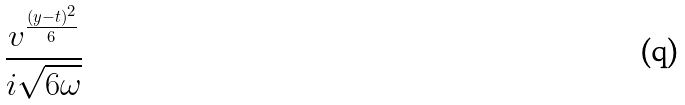<formula> <loc_0><loc_0><loc_500><loc_500>\frac { v ^ { \frac { ( y - t ) ^ { 2 } } { 6 } } } { i \sqrt { 6 \omega } }</formula> 